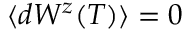<formula> <loc_0><loc_0><loc_500><loc_500>\langle d W ^ { z } ( T ) \rangle = 0</formula> 